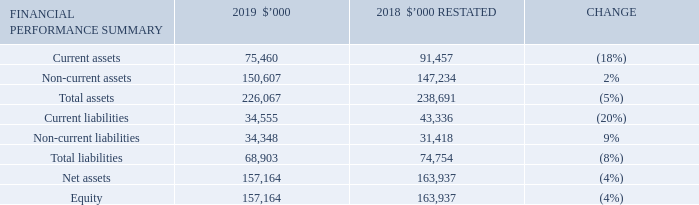Statement of financial position
Net assets have decreased to $157,164,000 at 30 June 2019 from $163,937,000 at 30 June 2018.
Current assets have decreased from 30 June 2018 by 18% to $75,460,000. This is driven by a reduction in cash assets, a result of continued investment in technology and further investment in iMoney. The current component of the trail commission asset is $25,626,000, which increased by 16% since 30 June 2018.
Non-current assets have increased from 30 June 2018 by 2% to $150,607,000 which is largely due to higher non-current trail commission asset partially offset by capital asset writeoffs and Home Loans Goodwill impairment. The non-current component of the trail commission asset is $88,452,000 which increased by 9% since 30 June 2018, mainly due to sales volume and partner mix.
Current liabilities decreased from 30 June 2018 to 30 June 2019 by 20% to $34,555,000 primarily due to payments to suppliers in addition to trade related payable balances post 30 June 2018.
Non-current liabilities have increased by 9% ending on $34,348,000. This relates to an increase in lease liabilities and deferred tax liabilities.
What is the percentage change in current assets from 2018 to 2019? 18%. What is the primary cause of the decrease in the current liabilities? Due to payments to suppliers in addition to trade related payable balances post 30 june 2018. What contributed to the increase in non-current liabilities in 2019? An increase in lease liabilities and deferred tax liabilities. What is the current ratio in 2019? 75,460/34,555
Answer: 2.18. What is the debts to assets ratio in 2019? 68,903/226,067
Answer: 0.3. What is the percentage change in the net assets from 2018 to 2019?
Answer scale should be: percent. (157,164-163,937)/163,937
Answer: -4.13. 